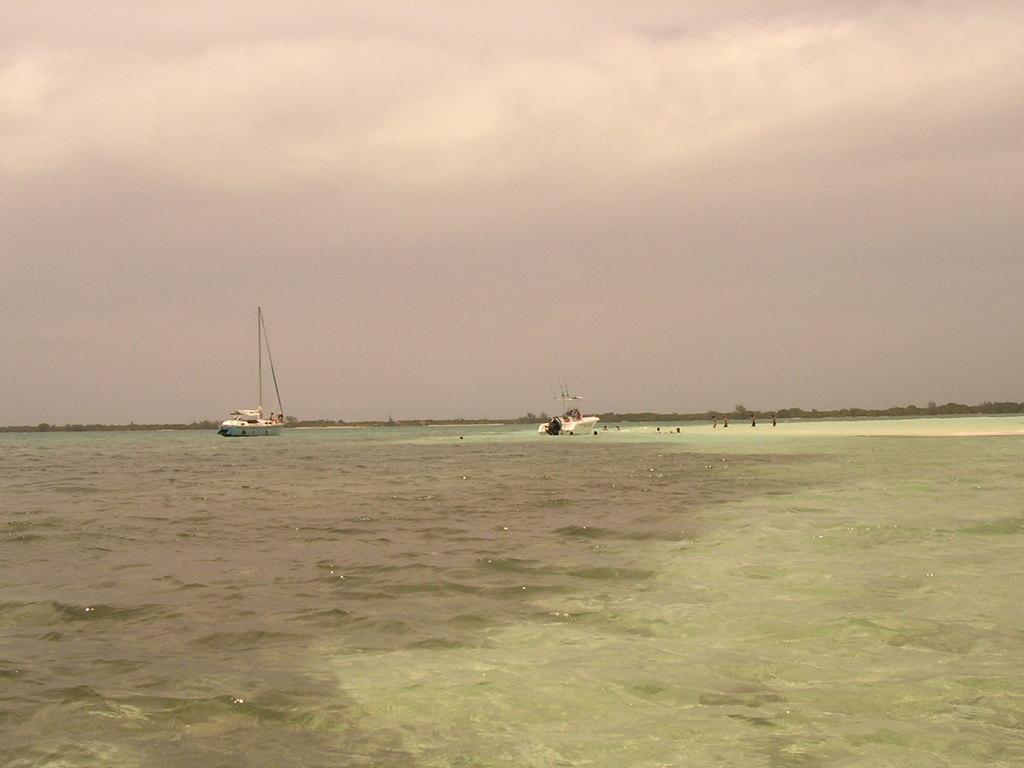What natural feature is present in the image? The image contains the sea. What objects can be seen in the sea? There are two boats in the sea. What is visible at the top of the image? The sky is visible at the top of the image. How many people are sleeping on the boats in the image? There is no information about people sleeping on the boats in the image. 